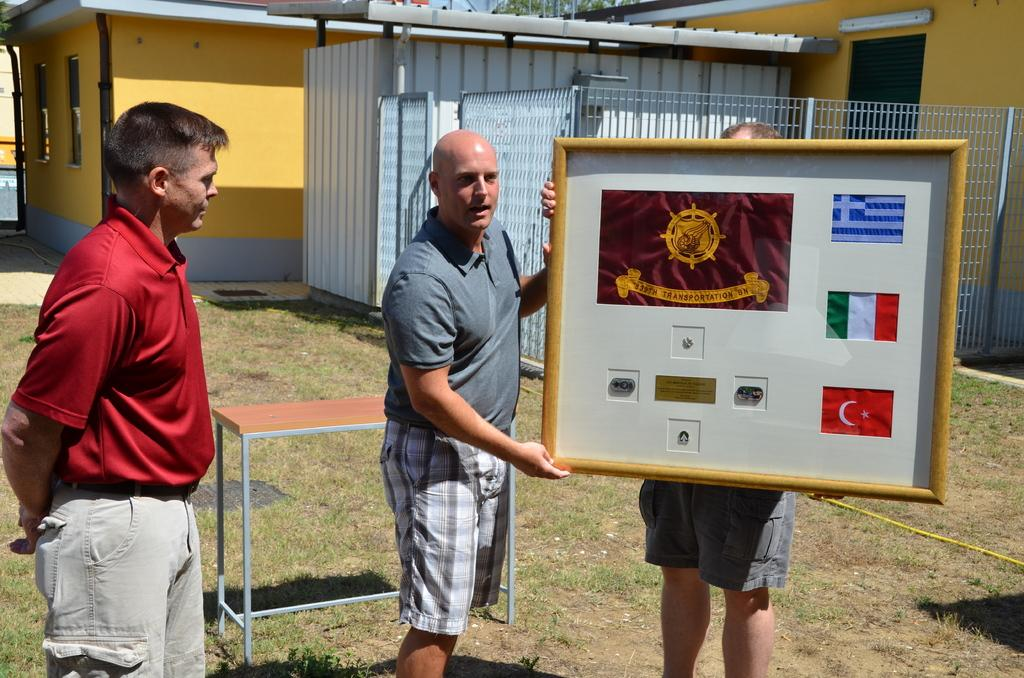How many people are standing on the grass in the image? There are 2 people standing on the grass in the image. What are the people holding? The people are holding a frame. Where is the person on the left side of the image standing? The person on the left side of the image is standing on the grass. What can be seen in the background of the image? There are buildings visible in the background of the image. Is there any fencing present in the image? Yes, there is a fence in the image. What type of fold can be seen in the image? There is no fold present in the image. How many trucks are visible in the image? There are no trucks visible in the image. 